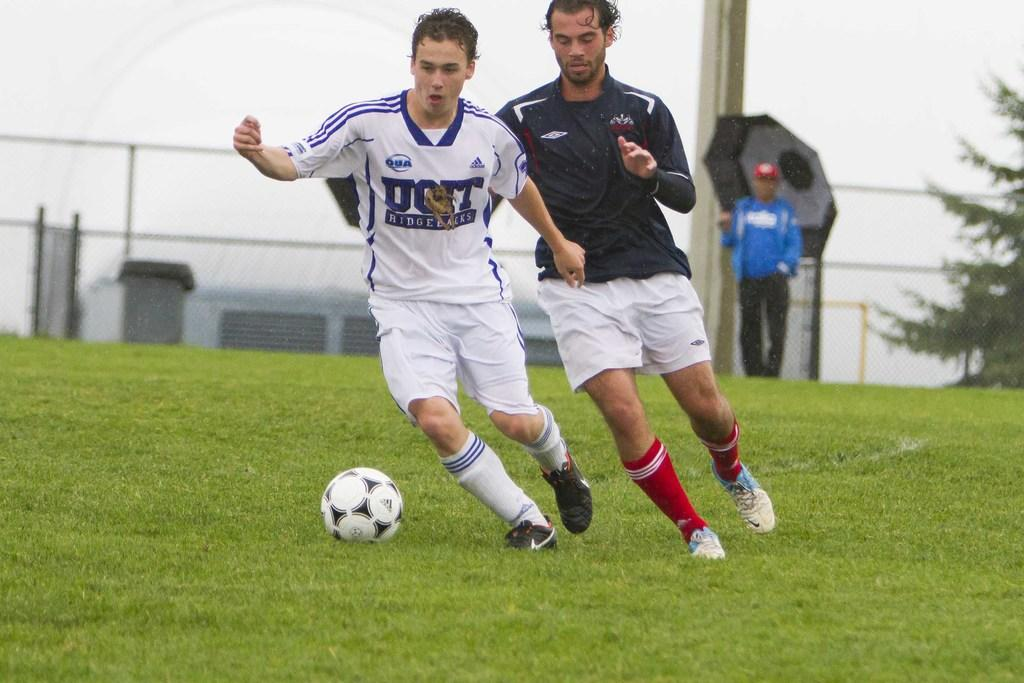What are the two persons in the image doing? The two persons in the image are playing football. What type of surface are they playing on? There is grass on the ground in the image. Can you describe the person in the background of the image? There is a person holding an umbrella in the background of the image. What is the reason for the bat to be present in the image? There is no bat present in the image. 